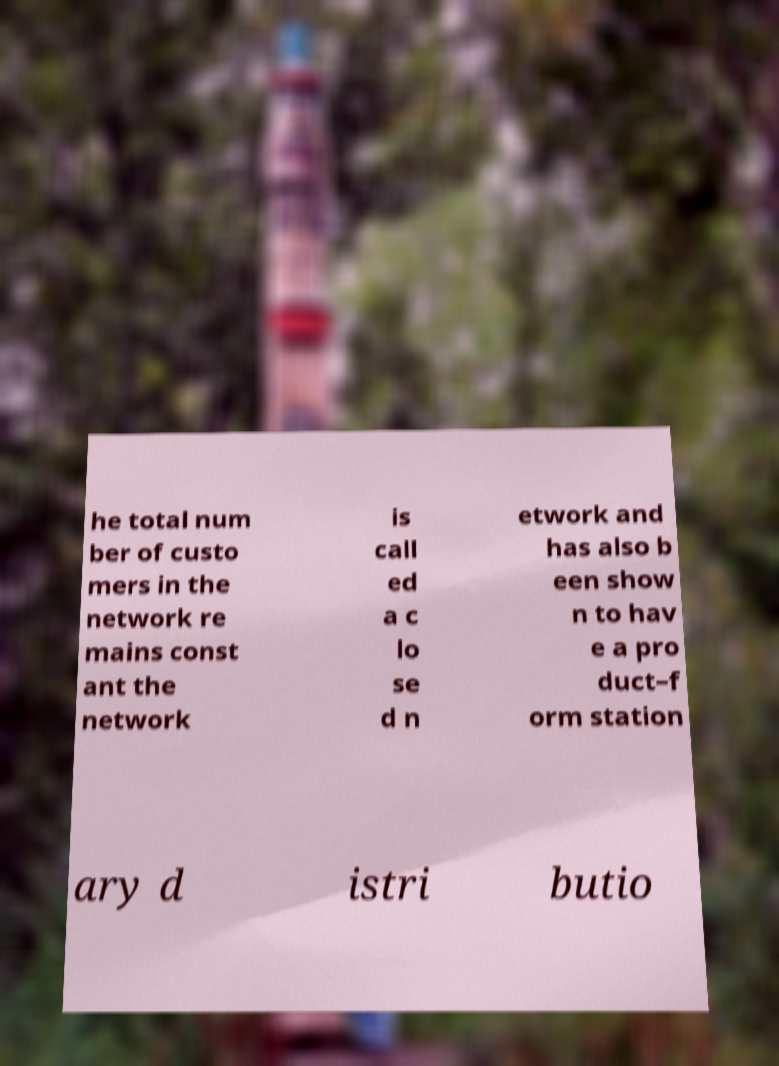I need the written content from this picture converted into text. Can you do that? he total num ber of custo mers in the network re mains const ant the network is call ed a c lo se d n etwork and has also b een show n to hav e a pro duct–f orm station ary d istri butio 